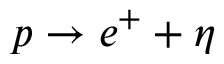<formula> <loc_0><loc_0><loc_500><loc_500>p \rightarrow e ^ { + } + \eta</formula> 